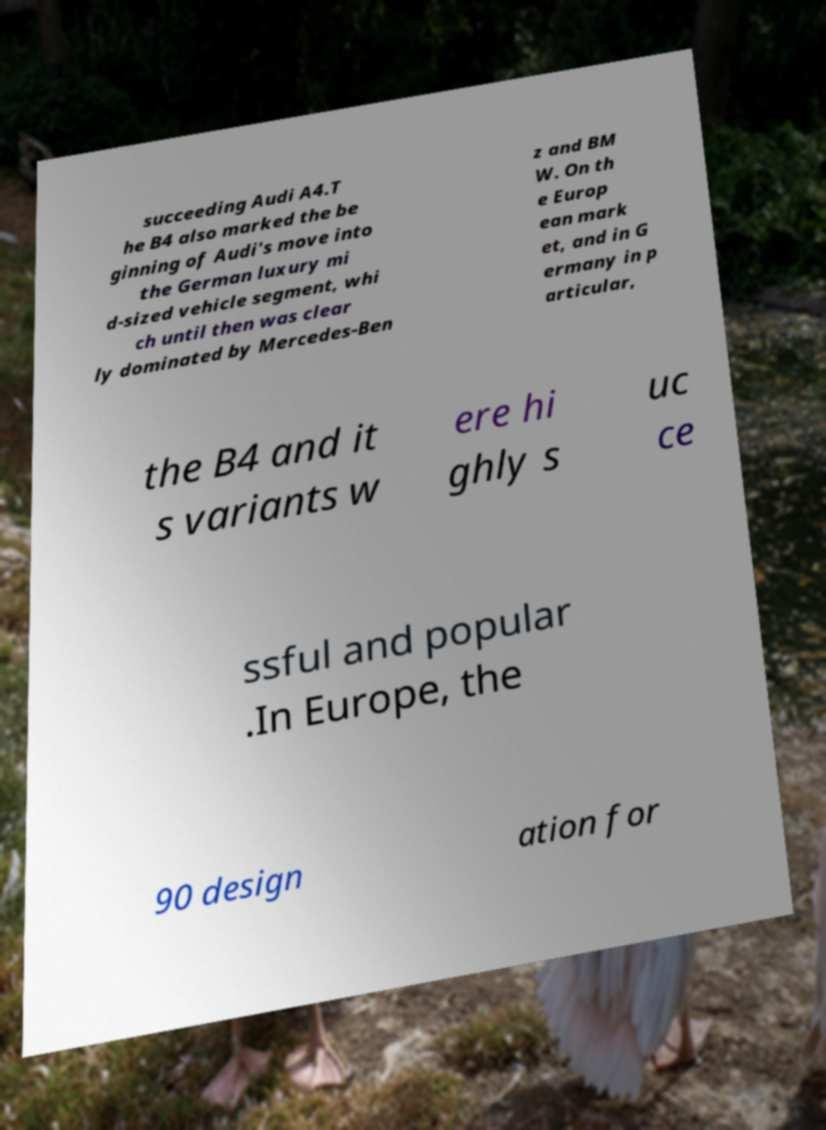There's text embedded in this image that I need extracted. Can you transcribe it verbatim? succeeding Audi A4.T he B4 also marked the be ginning of Audi's move into the German luxury mi d-sized vehicle segment, whi ch until then was clear ly dominated by Mercedes-Ben z and BM W. On th e Europ ean mark et, and in G ermany in p articular, the B4 and it s variants w ere hi ghly s uc ce ssful and popular .In Europe, the 90 design ation for 